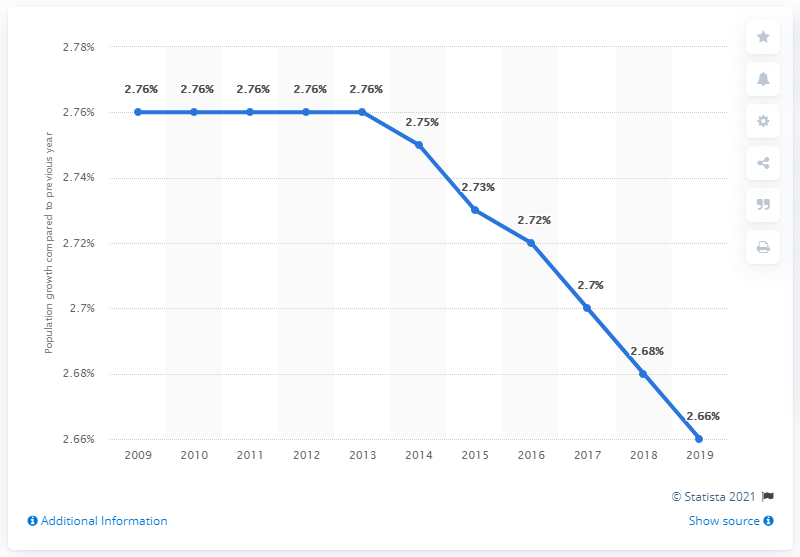List a handful of essential elements in this visual. The difference between the highest percentage and the lowest percentage is 0.1. The population remains the same for 5 years. 